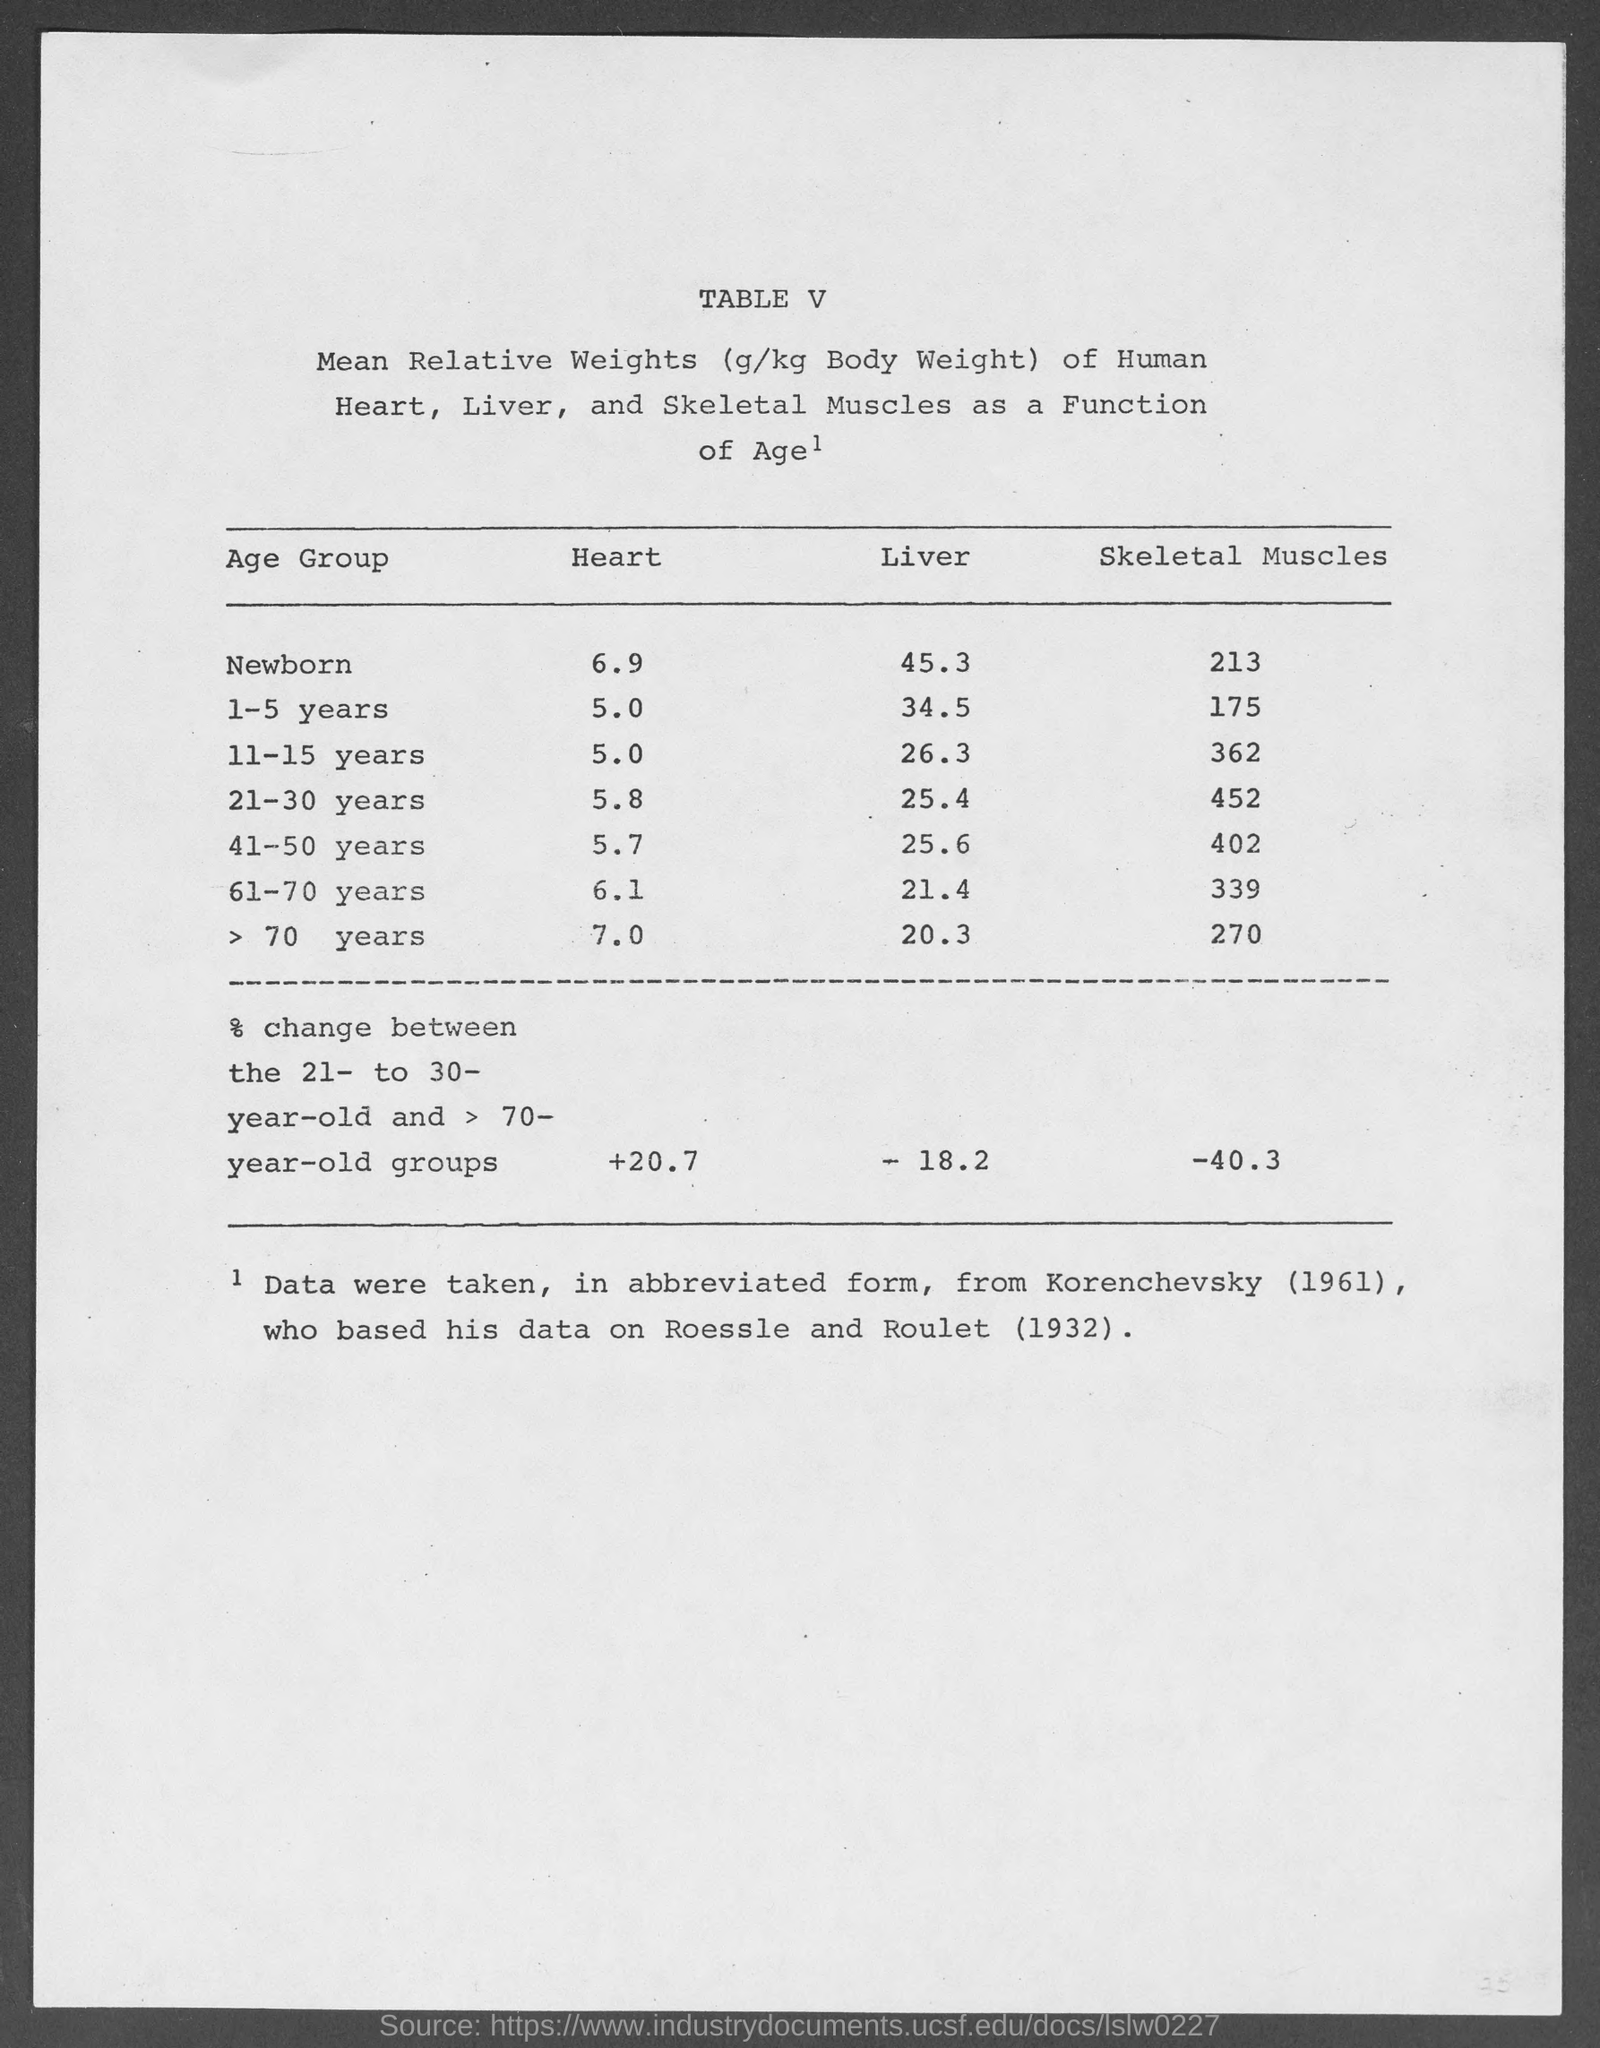Give some essential details in this illustration. The value written under the heading "Liver" for the age group 61-70 years is 21.4. The value written under "Liver" for individuals aged 11-15 years is 26.3. The value listed under the heading "Heart" for the age group 41-50 years is 5.7. The value of the % change between the 21- to 30-year-old and >70-year-old groups under the heading Skeletal Muscles is -40.3%. The capitalized text at the beginning of this document, which reads "What is written in capital letters as the first line at top of this document ? table v..", is a question asking for information about a table. 